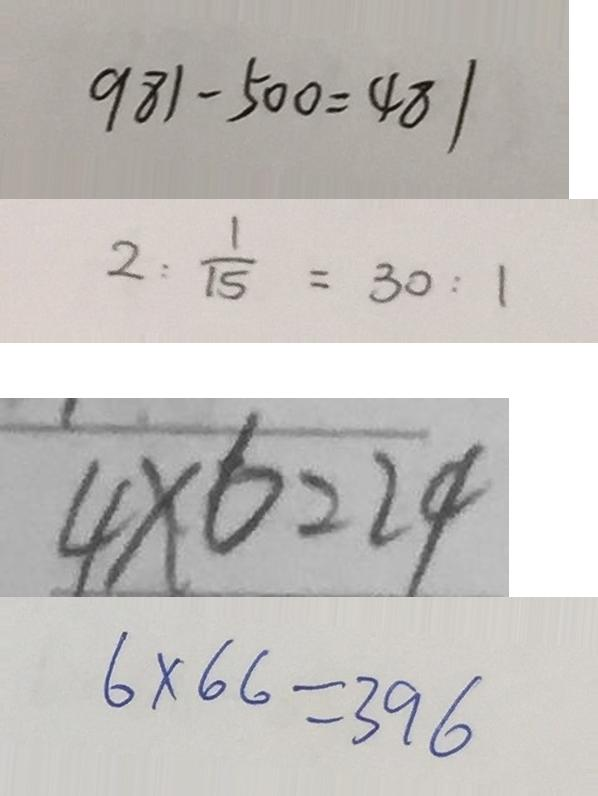Convert formula to latex. <formula><loc_0><loc_0><loc_500><loc_500>9 8 1 - 5 0 0 = 4 8 1 
 2 : \frac { 1 } { 1 5 } = 3 0 : 1 
 4 \times 6 = 2 4 
 6 \times 6 6 = 3 9 6</formula> 